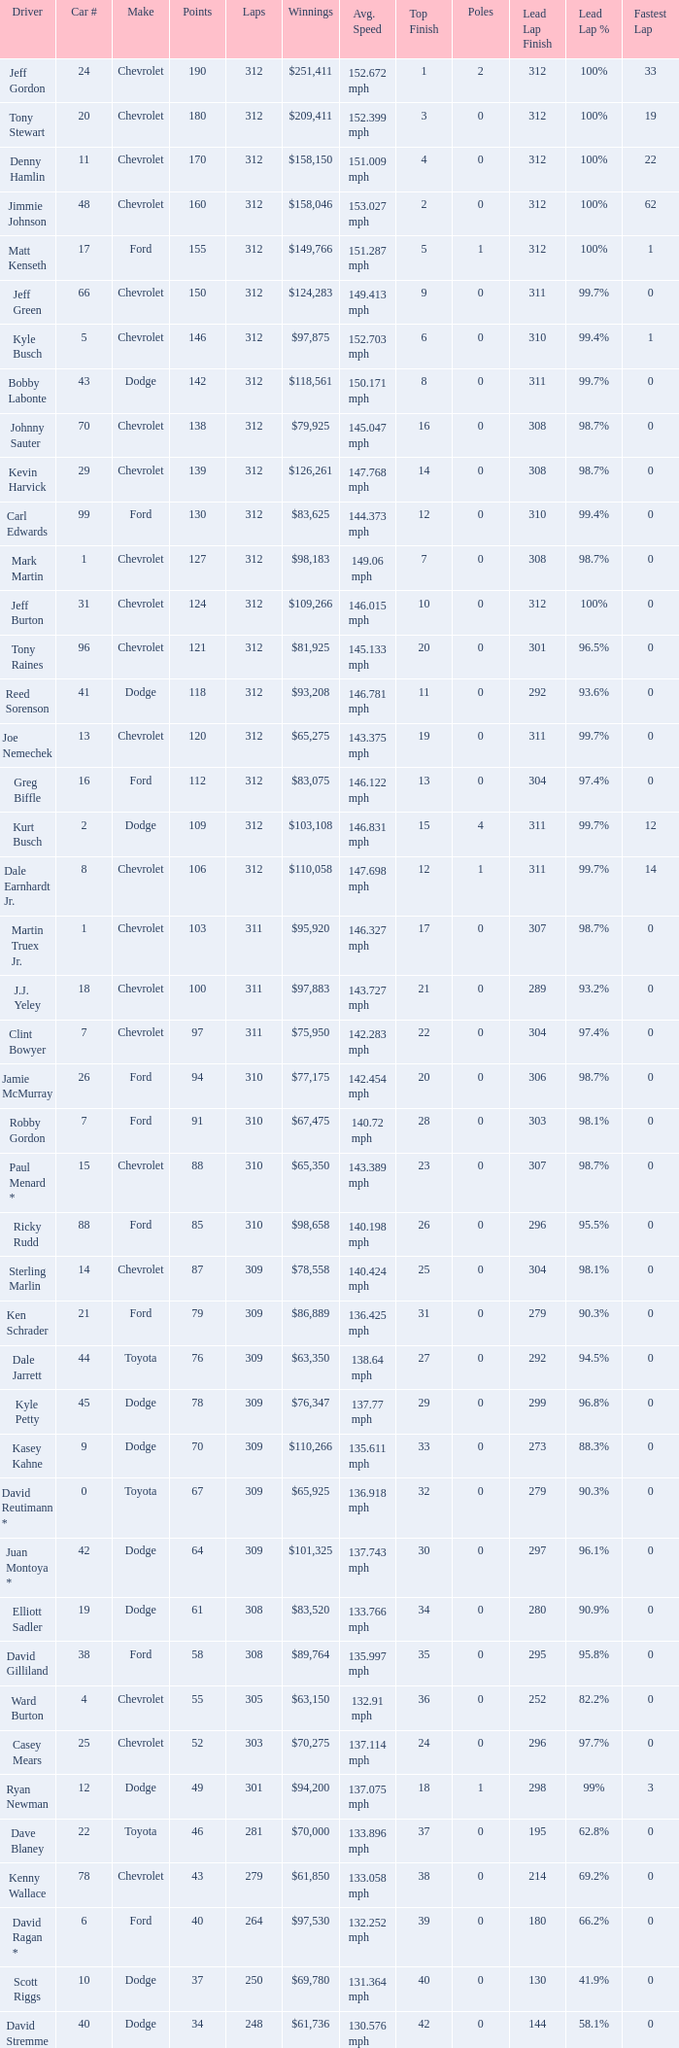What is the sum of laps that has a car number of larger than 1, is a ford, and has 155 points? 312.0. 